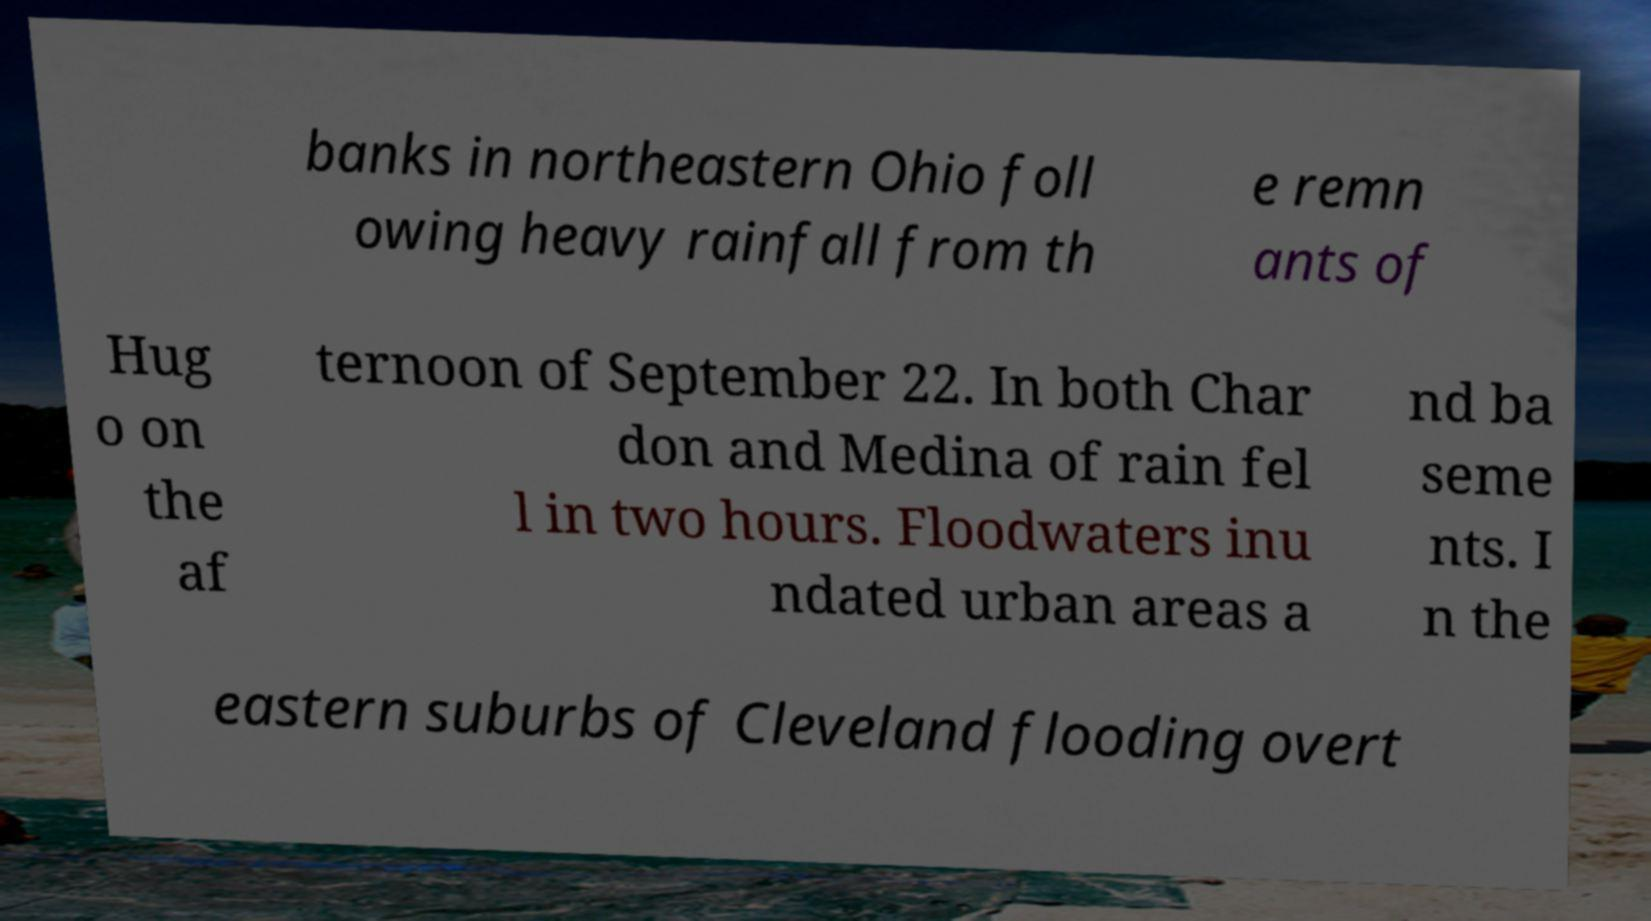What messages or text are displayed in this image? I need them in a readable, typed format. banks in northeastern Ohio foll owing heavy rainfall from th e remn ants of Hug o on the af ternoon of September 22. In both Char don and Medina of rain fel l in two hours. Floodwaters inu ndated urban areas a nd ba seme nts. I n the eastern suburbs of Cleveland flooding overt 